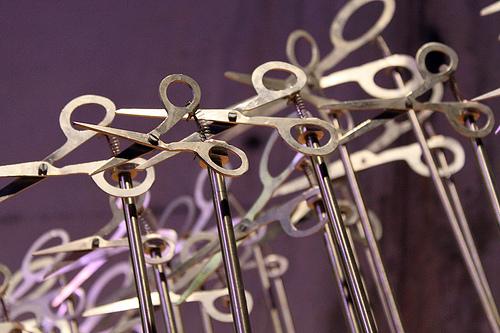How many scissors are there?
Concise answer only. 10. Why are scissors mounted like this?
Be succinct. Art. Are the scissors open or shut?
Give a very brief answer. Open. Are the scissors closed?
Quick response, please. No. 